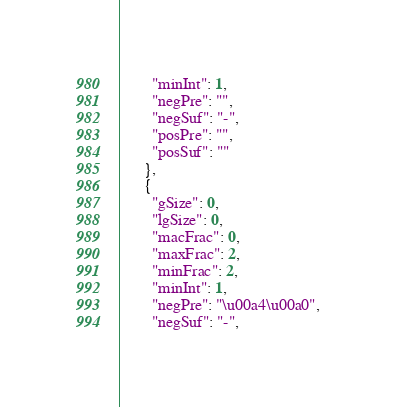<code> <loc_0><loc_0><loc_500><loc_500><_JavaScript_>        "minInt": 1,
        "negPre": "",
        "negSuf": "-",
        "posPre": "",
        "posSuf": ""
      },
      {
        "gSize": 0,
        "lgSize": 0,
        "macFrac": 0,
        "maxFrac": 2,
        "minFrac": 2,
        "minInt": 1,
        "negPre": "\u00a4\u00a0",
        "negSuf": "-",</code> 